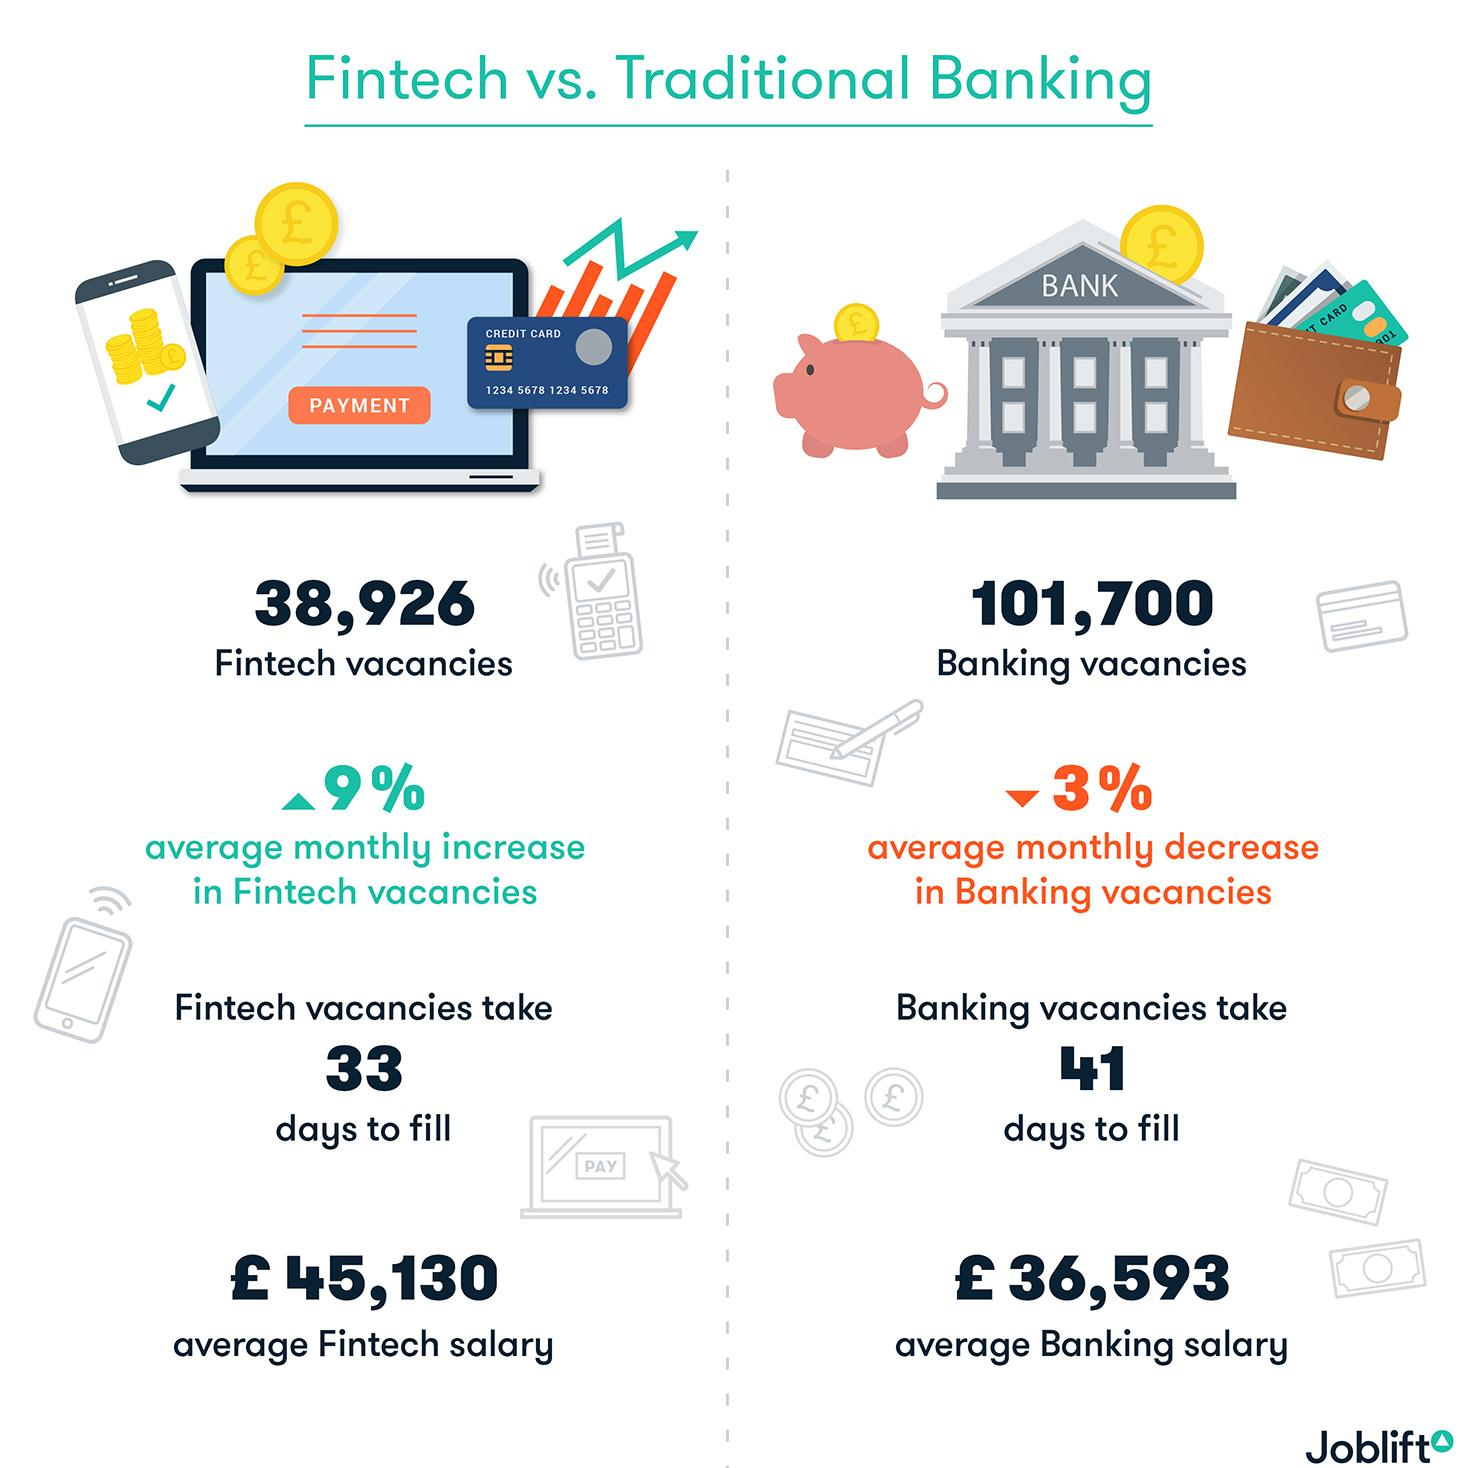Draw attention to some important aspects in this diagram. On average, there is a 3% decrease in banking vacancies each month. As of the current data available, there are 101,700 banking vacancies. There are a total of 140,626 vacancies in both the traditional banking and Fintech sectors. There are 38,926 Fintech job vacancies in the market. Fintech vacancies tend to fill up faster than other vacancies. 